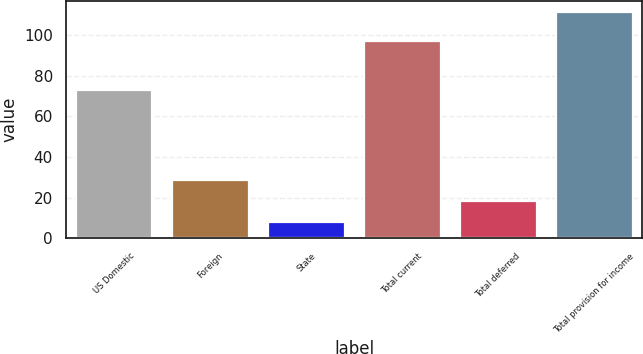Convert chart. <chart><loc_0><loc_0><loc_500><loc_500><bar_chart><fcel>US Domestic<fcel>Foreign<fcel>State<fcel>Total current<fcel>Total deferred<fcel>Total provision for income<nl><fcel>73.1<fcel>28.7<fcel>8.1<fcel>97<fcel>18.4<fcel>111.1<nl></chart> 